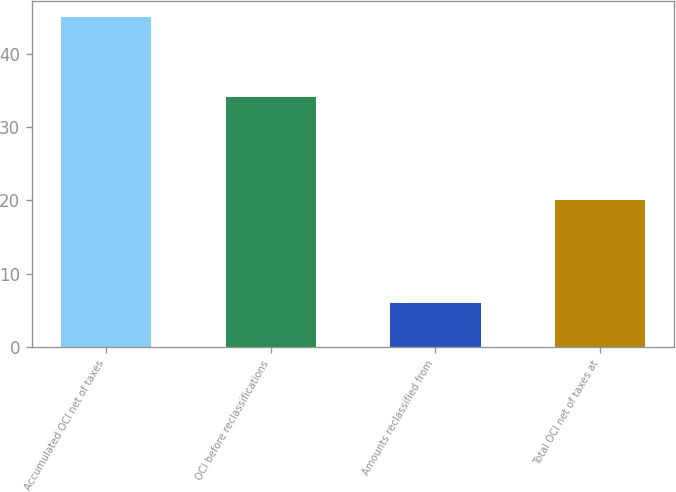Convert chart. <chart><loc_0><loc_0><loc_500><loc_500><bar_chart><fcel>Accumulated OCI net of taxes<fcel>OCI before reclassifications<fcel>Amounts reclassified from<fcel>Total OCI net of taxes at<nl><fcel>45<fcel>34.1<fcel>6<fcel>20<nl></chart> 